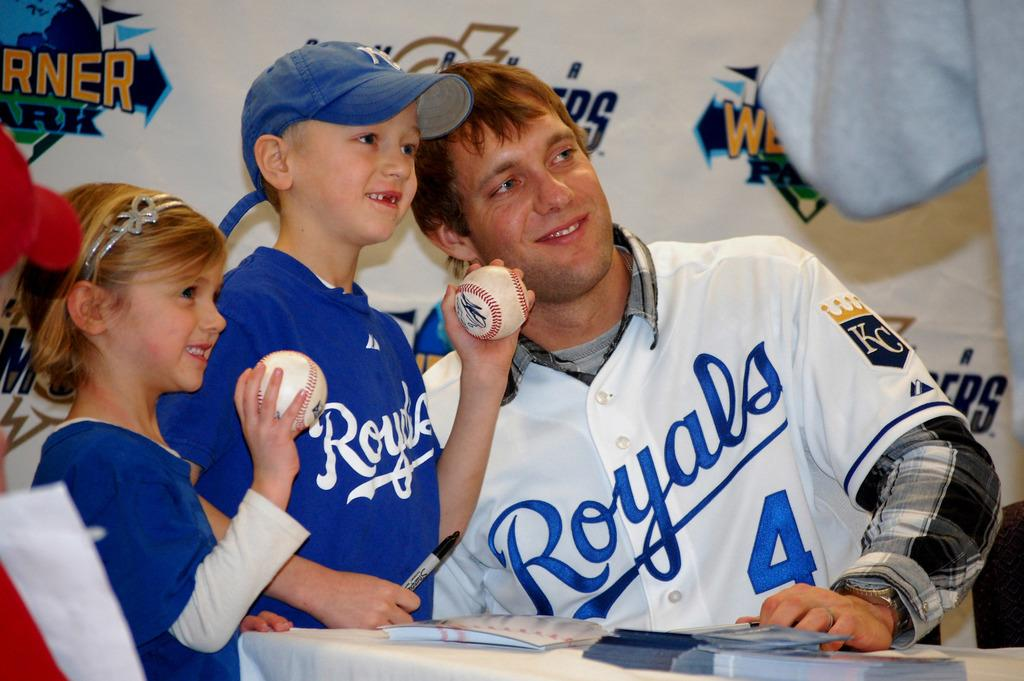Provide a one-sentence caption for the provided image. A player for the Royals poses with a couple of young fans. 